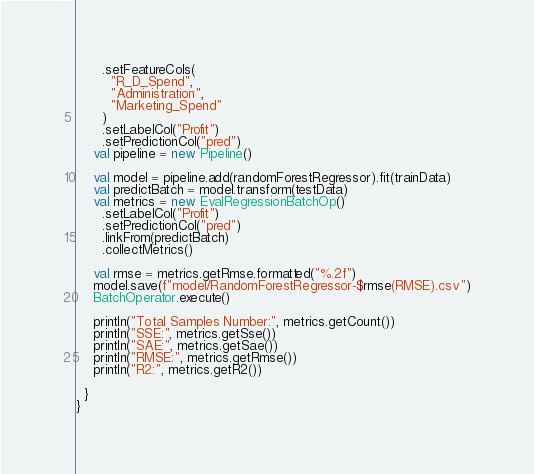<code> <loc_0><loc_0><loc_500><loc_500><_Scala_>      .setFeatureCols(
        "R_D_Spend",
        "Administration",
        "Marketing_Spend"
      )
      .setLabelCol("Profit")
      .setPredictionCol("pred")
    val pipeline = new Pipeline()

    val model = pipeline.add(randomForestRegressor).fit(trainData)
    val predictBatch = model.transform(testData)
    val metrics = new EvalRegressionBatchOp()
      .setLabelCol("Profit")
      .setPredictionCol("pred")
      .linkFrom(predictBatch)
      .collectMetrics()

    val rmse = metrics.getRmse.formatted("%.2f")
    model.save(f"model/RandomForestRegressor-$rmse(RMSE).csv")
    BatchOperator.execute()

    println("Total Samples Number:", metrics.getCount())
    println("SSE:", metrics.getSse())
    println("SAE:", metrics.getSae())
    println("RMSE:", metrics.getRmse())
    println("R2:", metrics.getR2())

  }
}
</code> 